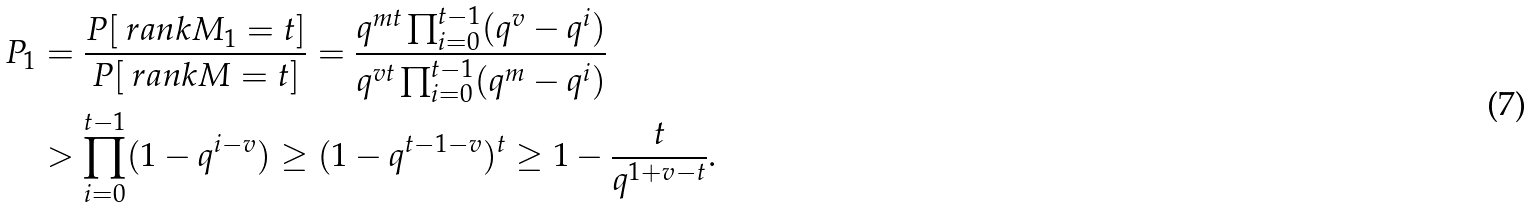<formula> <loc_0><loc_0><loc_500><loc_500>P _ { 1 } & = \frac { P [ \ r a n k M _ { 1 } = t ] } { P [ \ r a n k M = t ] } = \frac { q ^ { m t } \prod _ { i = 0 } ^ { t - 1 } ( q ^ { v } - q ^ { i } ) } { q ^ { v t } \prod _ { i = 0 } ^ { t - 1 } ( q ^ { m } - q ^ { i } ) } \\ & > \prod _ { i = 0 } ^ { t - 1 } ( 1 - q ^ { i - v } ) \geq ( 1 - q ^ { t - 1 - v } ) ^ { t } \geq 1 - \frac { t } { q ^ { 1 + v - t } } .</formula> 